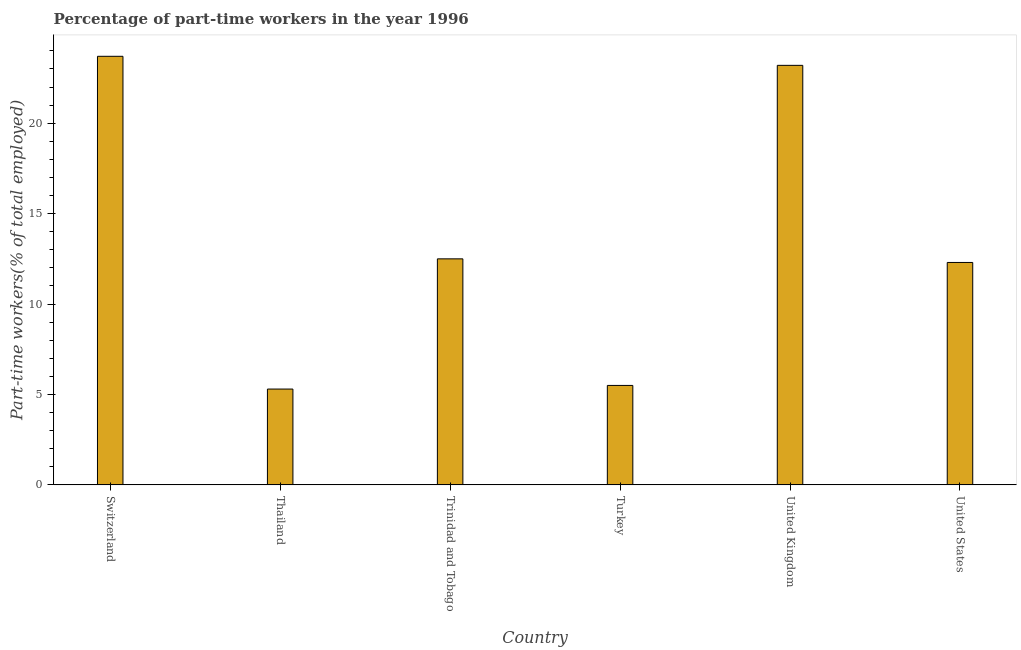Does the graph contain any zero values?
Give a very brief answer. No. Does the graph contain grids?
Your answer should be very brief. No. What is the title of the graph?
Give a very brief answer. Percentage of part-time workers in the year 1996. What is the label or title of the X-axis?
Ensure brevity in your answer.  Country. What is the label or title of the Y-axis?
Offer a very short reply. Part-time workers(% of total employed). What is the percentage of part-time workers in United Kingdom?
Make the answer very short. 23.2. Across all countries, what is the maximum percentage of part-time workers?
Provide a succinct answer. 23.7. Across all countries, what is the minimum percentage of part-time workers?
Provide a short and direct response. 5.3. In which country was the percentage of part-time workers maximum?
Your response must be concise. Switzerland. In which country was the percentage of part-time workers minimum?
Make the answer very short. Thailand. What is the sum of the percentage of part-time workers?
Keep it short and to the point. 82.5. What is the average percentage of part-time workers per country?
Offer a terse response. 13.75. What is the median percentage of part-time workers?
Offer a terse response. 12.4. What is the ratio of the percentage of part-time workers in Thailand to that in Turkey?
Provide a succinct answer. 0.96. Is the percentage of part-time workers in Switzerland less than that in Thailand?
Provide a succinct answer. No. Is the difference between the percentage of part-time workers in Thailand and United States greater than the difference between any two countries?
Make the answer very short. No. What is the difference between the highest and the second highest percentage of part-time workers?
Your answer should be very brief. 0.5. In how many countries, is the percentage of part-time workers greater than the average percentage of part-time workers taken over all countries?
Offer a terse response. 2. How many bars are there?
Your response must be concise. 6. How many countries are there in the graph?
Ensure brevity in your answer.  6. What is the difference between two consecutive major ticks on the Y-axis?
Provide a short and direct response. 5. Are the values on the major ticks of Y-axis written in scientific E-notation?
Your answer should be very brief. No. What is the Part-time workers(% of total employed) of Switzerland?
Give a very brief answer. 23.7. What is the Part-time workers(% of total employed) in Thailand?
Offer a terse response. 5.3. What is the Part-time workers(% of total employed) of Trinidad and Tobago?
Make the answer very short. 12.5. What is the Part-time workers(% of total employed) in Turkey?
Keep it short and to the point. 5.5. What is the Part-time workers(% of total employed) in United Kingdom?
Offer a terse response. 23.2. What is the Part-time workers(% of total employed) of United States?
Your answer should be very brief. 12.3. What is the difference between the Part-time workers(% of total employed) in Thailand and Trinidad and Tobago?
Provide a succinct answer. -7.2. What is the difference between the Part-time workers(% of total employed) in Thailand and Turkey?
Your answer should be compact. -0.2. What is the difference between the Part-time workers(% of total employed) in Thailand and United Kingdom?
Provide a succinct answer. -17.9. What is the difference between the Part-time workers(% of total employed) in Trinidad and Tobago and Turkey?
Ensure brevity in your answer.  7. What is the difference between the Part-time workers(% of total employed) in Trinidad and Tobago and United Kingdom?
Your response must be concise. -10.7. What is the difference between the Part-time workers(% of total employed) in Trinidad and Tobago and United States?
Provide a succinct answer. 0.2. What is the difference between the Part-time workers(% of total employed) in Turkey and United Kingdom?
Offer a terse response. -17.7. What is the difference between the Part-time workers(% of total employed) in Turkey and United States?
Provide a succinct answer. -6.8. What is the ratio of the Part-time workers(% of total employed) in Switzerland to that in Thailand?
Ensure brevity in your answer.  4.47. What is the ratio of the Part-time workers(% of total employed) in Switzerland to that in Trinidad and Tobago?
Your answer should be compact. 1.9. What is the ratio of the Part-time workers(% of total employed) in Switzerland to that in Turkey?
Your answer should be very brief. 4.31. What is the ratio of the Part-time workers(% of total employed) in Switzerland to that in United States?
Provide a short and direct response. 1.93. What is the ratio of the Part-time workers(% of total employed) in Thailand to that in Trinidad and Tobago?
Provide a succinct answer. 0.42. What is the ratio of the Part-time workers(% of total employed) in Thailand to that in Turkey?
Provide a succinct answer. 0.96. What is the ratio of the Part-time workers(% of total employed) in Thailand to that in United Kingdom?
Provide a short and direct response. 0.23. What is the ratio of the Part-time workers(% of total employed) in Thailand to that in United States?
Keep it short and to the point. 0.43. What is the ratio of the Part-time workers(% of total employed) in Trinidad and Tobago to that in Turkey?
Give a very brief answer. 2.27. What is the ratio of the Part-time workers(% of total employed) in Trinidad and Tobago to that in United Kingdom?
Offer a very short reply. 0.54. What is the ratio of the Part-time workers(% of total employed) in Turkey to that in United Kingdom?
Provide a short and direct response. 0.24. What is the ratio of the Part-time workers(% of total employed) in Turkey to that in United States?
Ensure brevity in your answer.  0.45. What is the ratio of the Part-time workers(% of total employed) in United Kingdom to that in United States?
Your answer should be very brief. 1.89. 